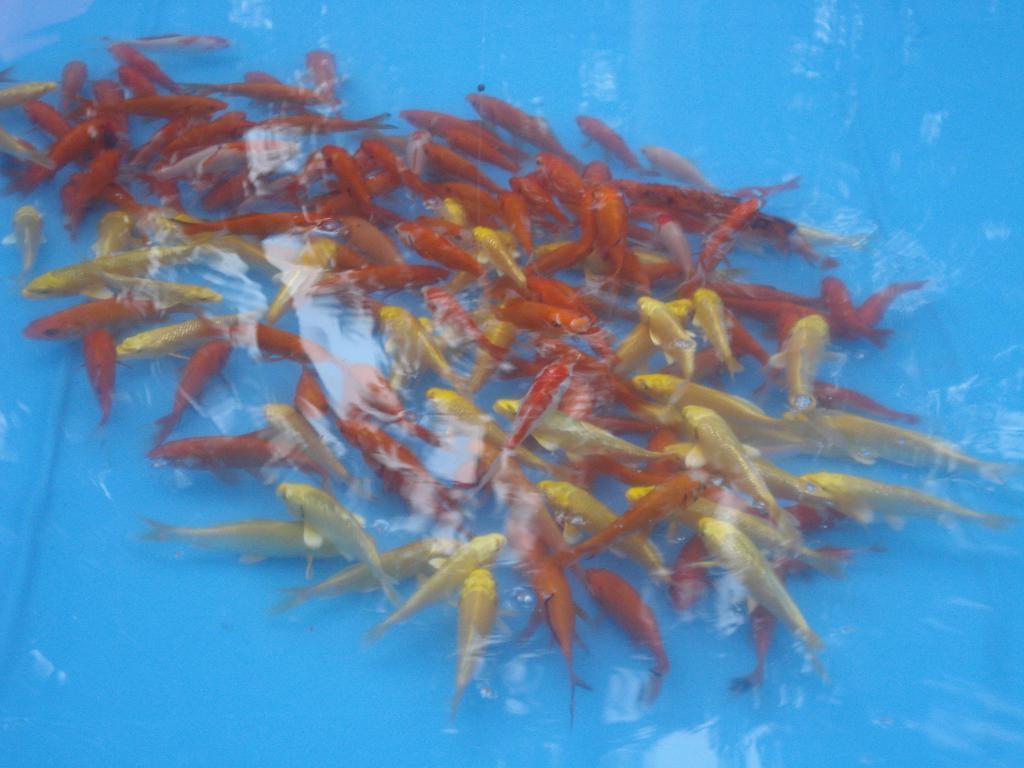Could you give a brief overview of what you see in this image? In this image I can see number of fishes which are orange, yellow and gold in color in the water and I can see the blue colored background. 